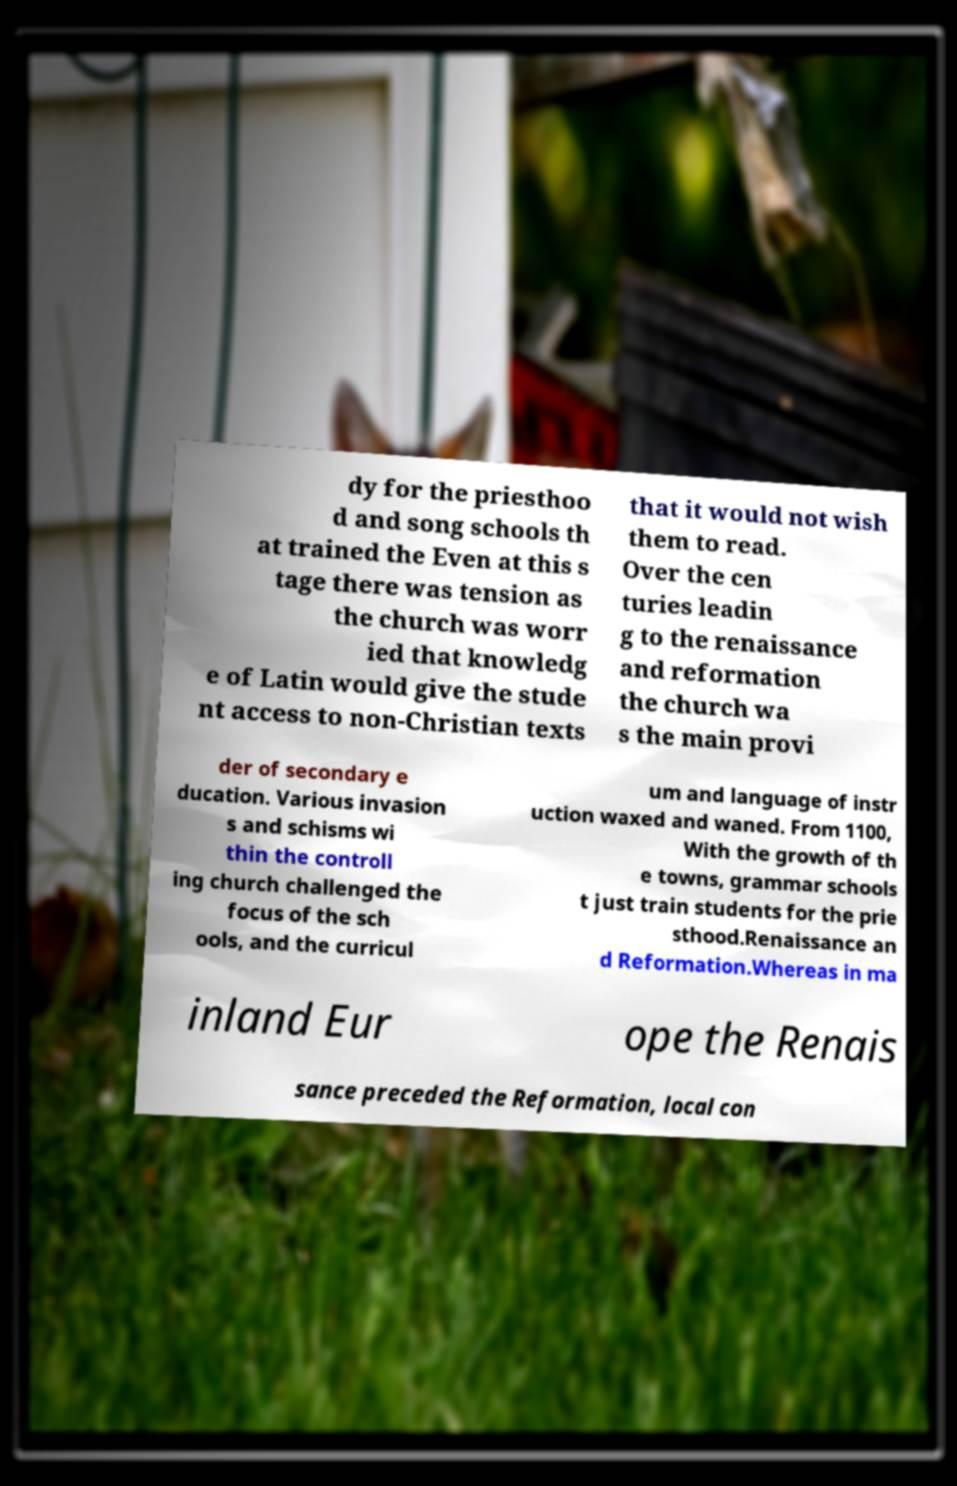Can you read and provide the text displayed in the image?This photo seems to have some interesting text. Can you extract and type it out for me? dy for the priesthoo d and song schools th at trained the Even at this s tage there was tension as the church was worr ied that knowledg e of Latin would give the stude nt access to non-Christian texts that it would not wish them to read. Over the cen turies leadin g to the renaissance and reformation the church wa s the main provi der of secondary e ducation. Various invasion s and schisms wi thin the controll ing church challenged the focus of the sch ools, and the curricul um and language of instr uction waxed and waned. From 1100, With the growth of th e towns, grammar schools t just train students for the prie sthood.Renaissance an d Reformation.Whereas in ma inland Eur ope the Renais sance preceded the Reformation, local con 